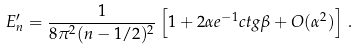Convert formula to latex. <formula><loc_0><loc_0><loc_500><loc_500>E ^ { \prime } _ { n } = \frac { 1 } { 8 \pi ^ { 2 } ( n - 1 / 2 ) ^ { 2 } } \left [ 1 + 2 \alpha e ^ { - 1 } c t g \beta + O ( \alpha ^ { 2 } ) \right ] \, .</formula> 